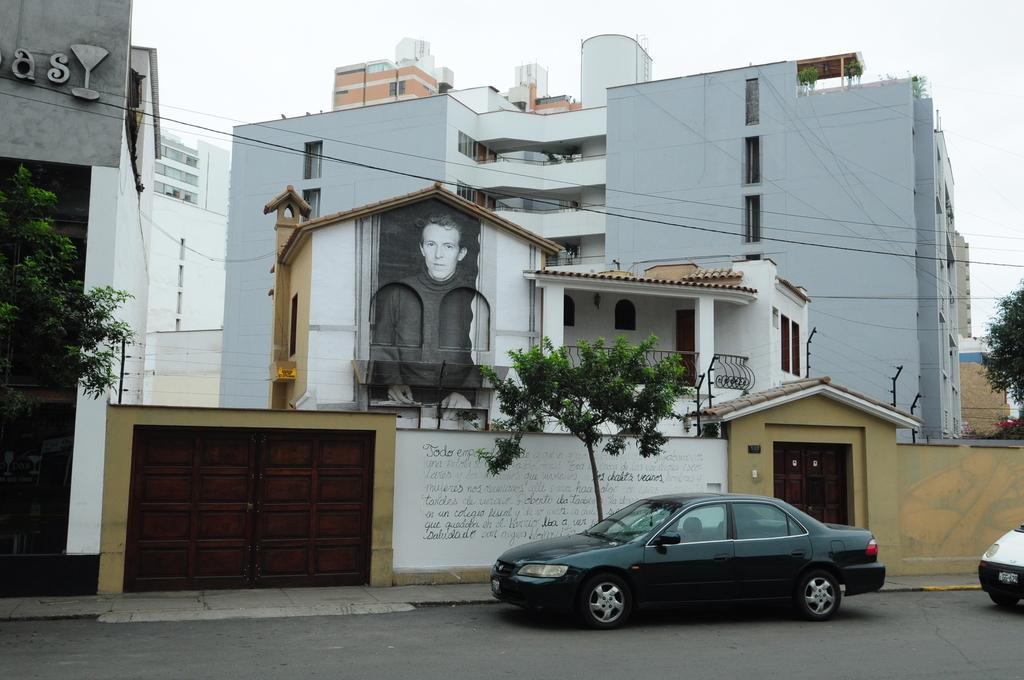What can be seen moving on the road in the image? There are vehicles on the road in the image. What type of structures are present in the image? There are buildings in the image. What type of vegetation is visible in the image? There are trees in the image. What is visible in the background of the image? The sky is visible in the background of the image. Where is the heart-shaped balloon located in the image? There is no heart-shaped balloon present in the image. What type of party is taking place in the image? There is no party depicted in the image. Can you tell me which airport is visible in the image? There is no airport present in the image. 